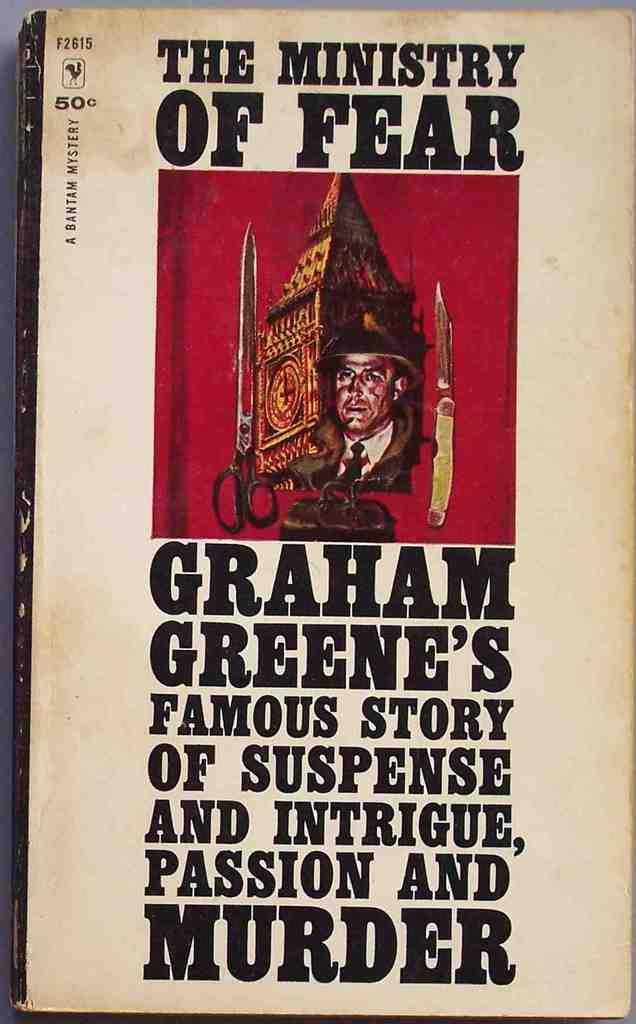Provide a one-sentence caption for the provided image. The cover of The Ministry of Fear depicting a picture of a man with weapons and the description of Graham Green's famous story of suspense and intrigue, passion and murder. 